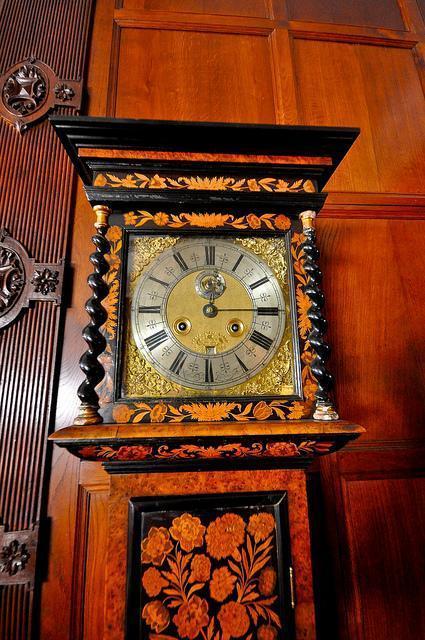How many brown cows are in this image?
Give a very brief answer. 0. 